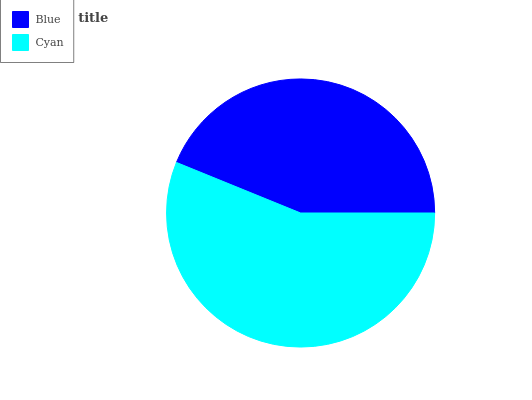Is Blue the minimum?
Answer yes or no. Yes. Is Cyan the maximum?
Answer yes or no. Yes. Is Cyan the minimum?
Answer yes or no. No. Is Cyan greater than Blue?
Answer yes or no. Yes. Is Blue less than Cyan?
Answer yes or no. Yes. Is Blue greater than Cyan?
Answer yes or no. No. Is Cyan less than Blue?
Answer yes or no. No. Is Cyan the high median?
Answer yes or no. Yes. Is Blue the low median?
Answer yes or no. Yes. Is Blue the high median?
Answer yes or no. No. Is Cyan the low median?
Answer yes or no. No. 